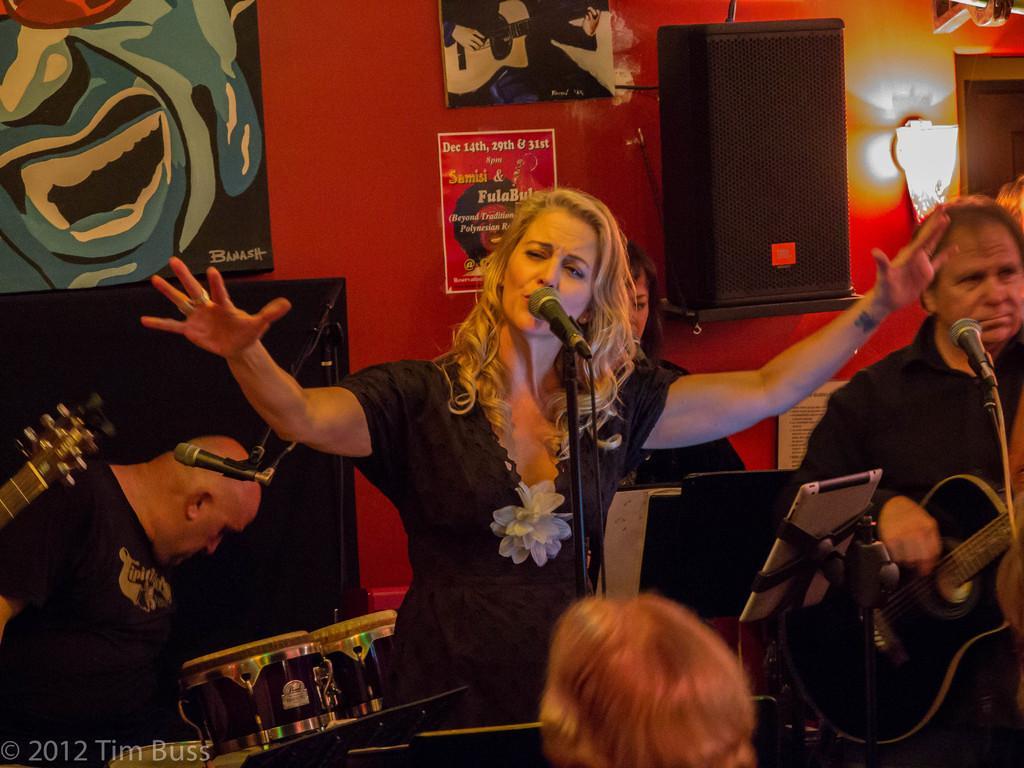Please provide a concise description of this image. This picture is clicked in a musical concert. Woman in black t-shirt is singing song on the microphone in front of her. Beside her, we see a man playing drums and behind them, we see a wall which is red in color and we even see some photo frames and posters are placed on that wall. 